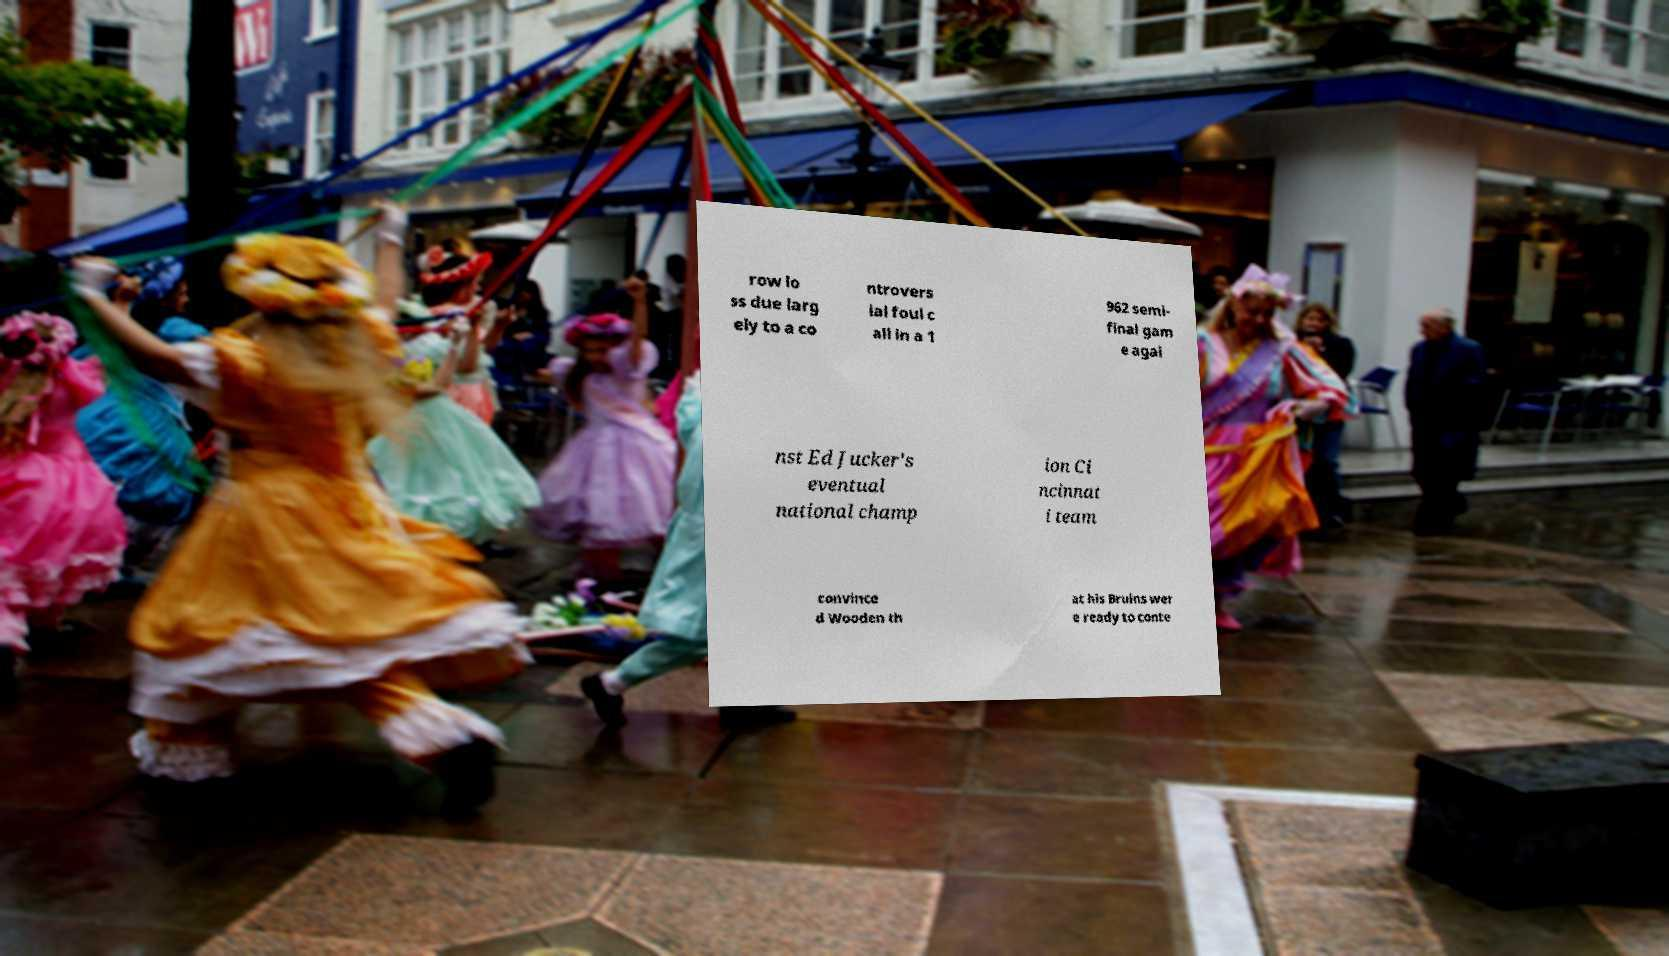Could you extract and type out the text from this image? row lo ss due larg ely to a co ntrovers ial foul c all in a 1 962 semi- final gam e agai nst Ed Jucker's eventual national champ ion Ci ncinnat i team convince d Wooden th at his Bruins wer e ready to conte 